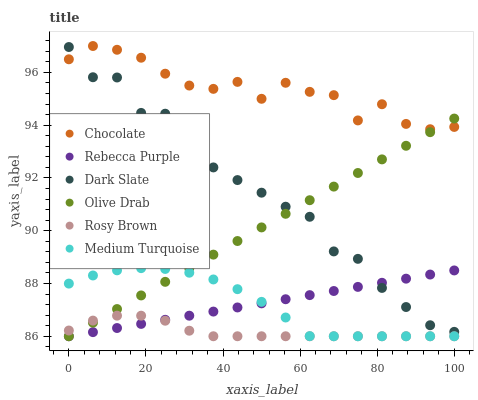Does Rosy Brown have the minimum area under the curve?
Answer yes or no. Yes. Does Chocolate have the maximum area under the curve?
Answer yes or no. Yes. Does Dark Slate have the minimum area under the curve?
Answer yes or no. No. Does Dark Slate have the maximum area under the curve?
Answer yes or no. No. Is Olive Drab the smoothest?
Answer yes or no. Yes. Is Chocolate the roughest?
Answer yes or no. Yes. Is Dark Slate the smoothest?
Answer yes or no. No. Is Dark Slate the roughest?
Answer yes or no. No. Does Rosy Brown have the lowest value?
Answer yes or no. Yes. Does Dark Slate have the lowest value?
Answer yes or no. No. Does Chocolate have the highest value?
Answer yes or no. Yes. Does Dark Slate have the highest value?
Answer yes or no. No. Is Medium Turquoise less than Chocolate?
Answer yes or no. Yes. Is Chocolate greater than Rosy Brown?
Answer yes or no. Yes. Does Dark Slate intersect Olive Drab?
Answer yes or no. Yes. Is Dark Slate less than Olive Drab?
Answer yes or no. No. Is Dark Slate greater than Olive Drab?
Answer yes or no. No. Does Medium Turquoise intersect Chocolate?
Answer yes or no. No. 